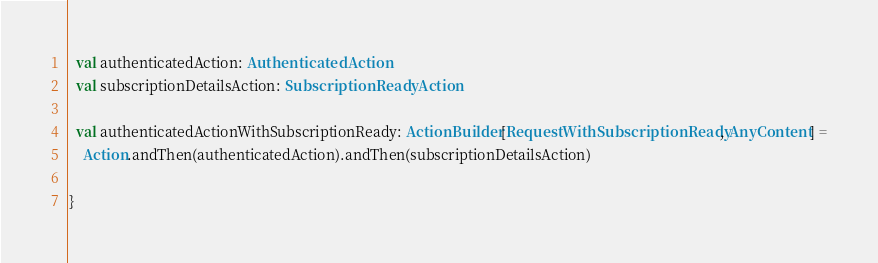<code> <loc_0><loc_0><loc_500><loc_500><_Scala_>  val authenticatedAction: AuthenticatedAction
  val subscriptionDetailsAction: SubscriptionReadyAction

  val authenticatedActionWithSubscriptionReady: ActionBuilder[RequestWithSubscriptionReady, AnyContent] =
    Action.andThen(authenticatedAction).andThen(subscriptionDetailsAction)

}
</code> 